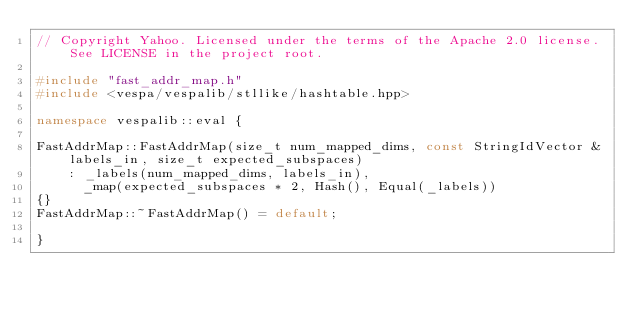Convert code to text. <code><loc_0><loc_0><loc_500><loc_500><_C++_>// Copyright Yahoo. Licensed under the terms of the Apache 2.0 license. See LICENSE in the project root.

#include "fast_addr_map.h"
#include <vespa/vespalib/stllike/hashtable.hpp>

namespace vespalib::eval {

FastAddrMap::FastAddrMap(size_t num_mapped_dims, const StringIdVector &labels_in, size_t expected_subspaces)
    : _labels(num_mapped_dims, labels_in),
      _map(expected_subspaces * 2, Hash(), Equal(_labels))
{}
FastAddrMap::~FastAddrMap() = default;

}
</code> 